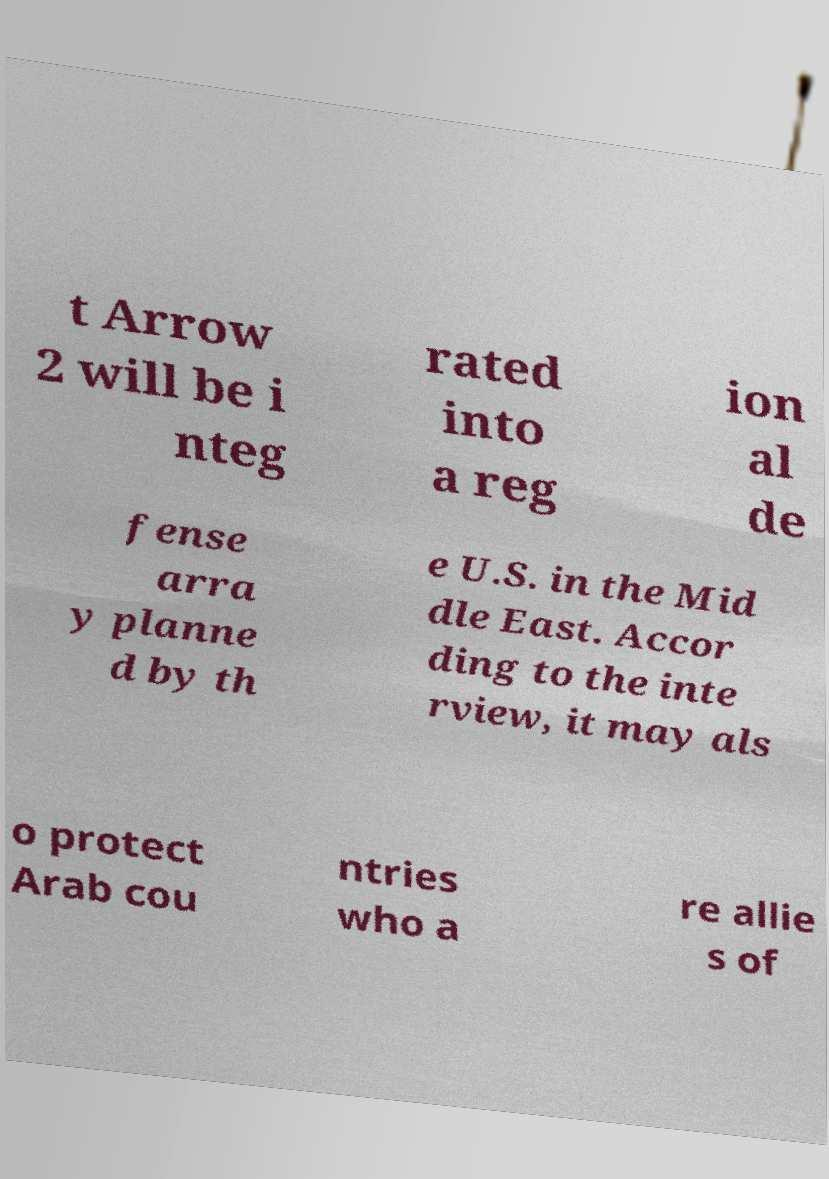There's text embedded in this image that I need extracted. Can you transcribe it verbatim? t Arrow 2 will be i nteg rated into a reg ion al de fense arra y planne d by th e U.S. in the Mid dle East. Accor ding to the inte rview, it may als o protect Arab cou ntries who a re allie s of 